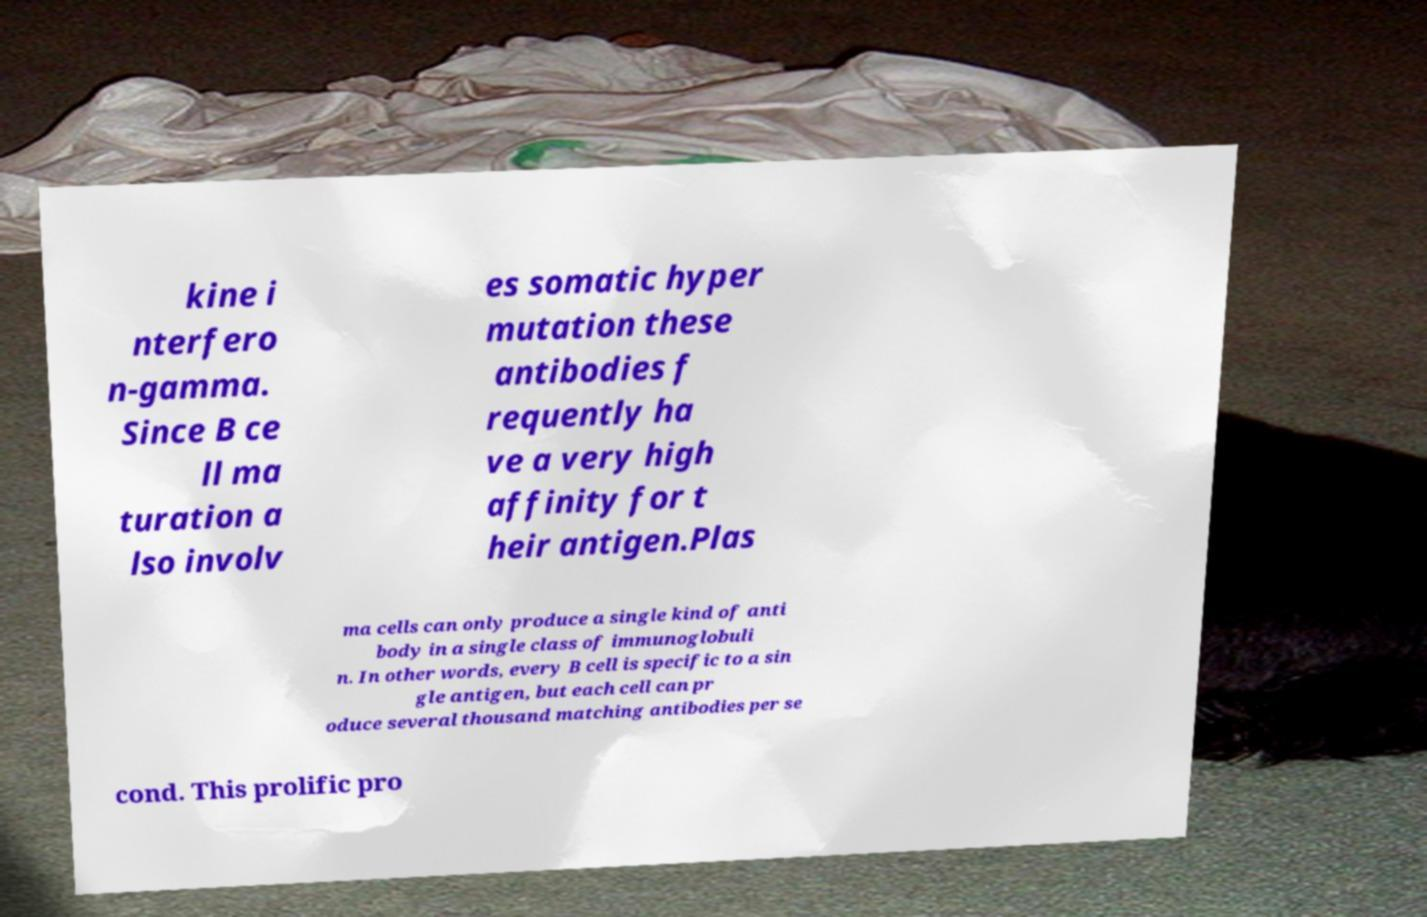Can you accurately transcribe the text from the provided image for me? kine i nterfero n-gamma. Since B ce ll ma turation a lso involv es somatic hyper mutation these antibodies f requently ha ve a very high affinity for t heir antigen.Plas ma cells can only produce a single kind of anti body in a single class of immunoglobuli n. In other words, every B cell is specific to a sin gle antigen, but each cell can pr oduce several thousand matching antibodies per se cond. This prolific pro 